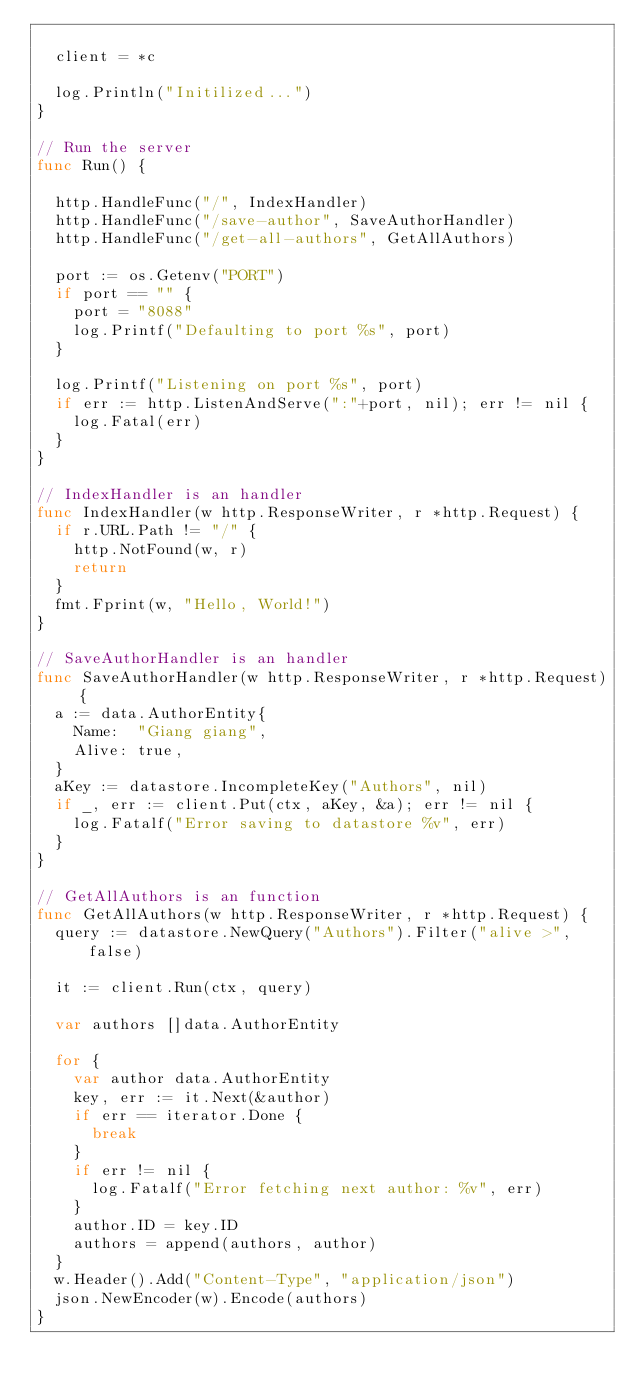Convert code to text. <code><loc_0><loc_0><loc_500><loc_500><_Go_>
	client = *c

	log.Println("Initilized...")
}

// Run the server
func Run() {

	http.HandleFunc("/", IndexHandler)
	http.HandleFunc("/save-author", SaveAuthorHandler)
	http.HandleFunc("/get-all-authors", GetAllAuthors)

	port := os.Getenv("PORT")
	if port == "" {
		port = "8088"
		log.Printf("Defaulting to port %s", port)
	}

	log.Printf("Listening on port %s", port)
	if err := http.ListenAndServe(":"+port, nil); err != nil {
		log.Fatal(err)
	}
}

// IndexHandler is an handler
func IndexHandler(w http.ResponseWriter, r *http.Request) {
	if r.URL.Path != "/" {
		http.NotFound(w, r)
		return
	}
	fmt.Fprint(w, "Hello, World!")
}

// SaveAuthorHandler is an handler
func SaveAuthorHandler(w http.ResponseWriter, r *http.Request) {
	a := data.AuthorEntity{
		Name:  "Giang giang",
		Alive: true,
	}
	aKey := datastore.IncompleteKey("Authors", nil)
	if _, err := client.Put(ctx, aKey, &a); err != nil {
		log.Fatalf("Error saving to datastore %v", err)
	}
}

// GetAllAuthors is an function
func GetAllAuthors(w http.ResponseWriter, r *http.Request) {
	query := datastore.NewQuery("Authors").Filter("alive >", false)

	it := client.Run(ctx, query)

	var authors []data.AuthorEntity

	for {
		var author data.AuthorEntity
		key, err := it.Next(&author)
		if err == iterator.Done {
			break
		}
		if err != nil {
			log.Fatalf("Error fetching next author: %v", err)
		}
		author.ID = key.ID
		authors = append(authors, author)
	}
	w.Header().Add("Content-Type", "application/json")
	json.NewEncoder(w).Encode(authors)
}
</code> 